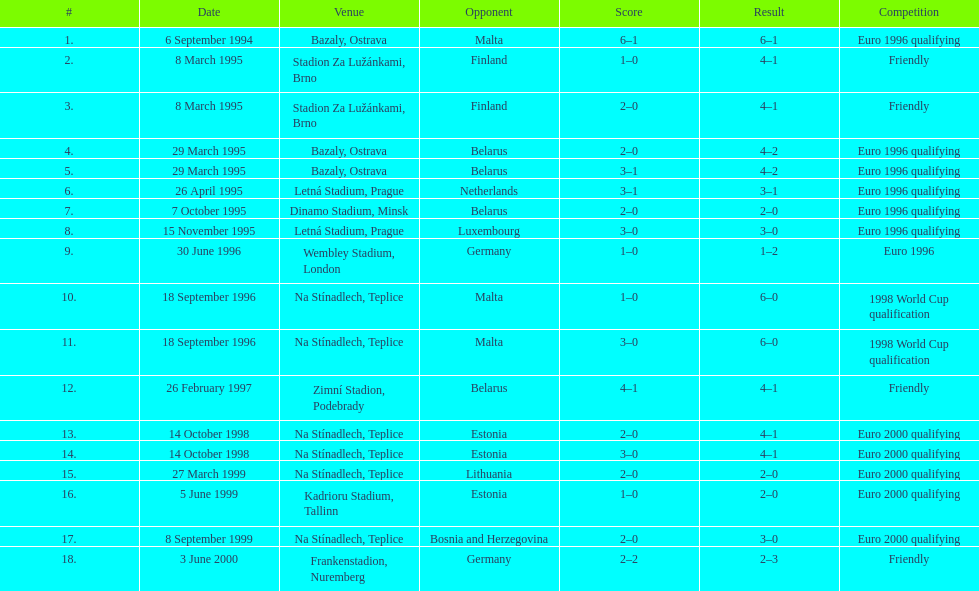How many games were played in total in 1999? 3. 